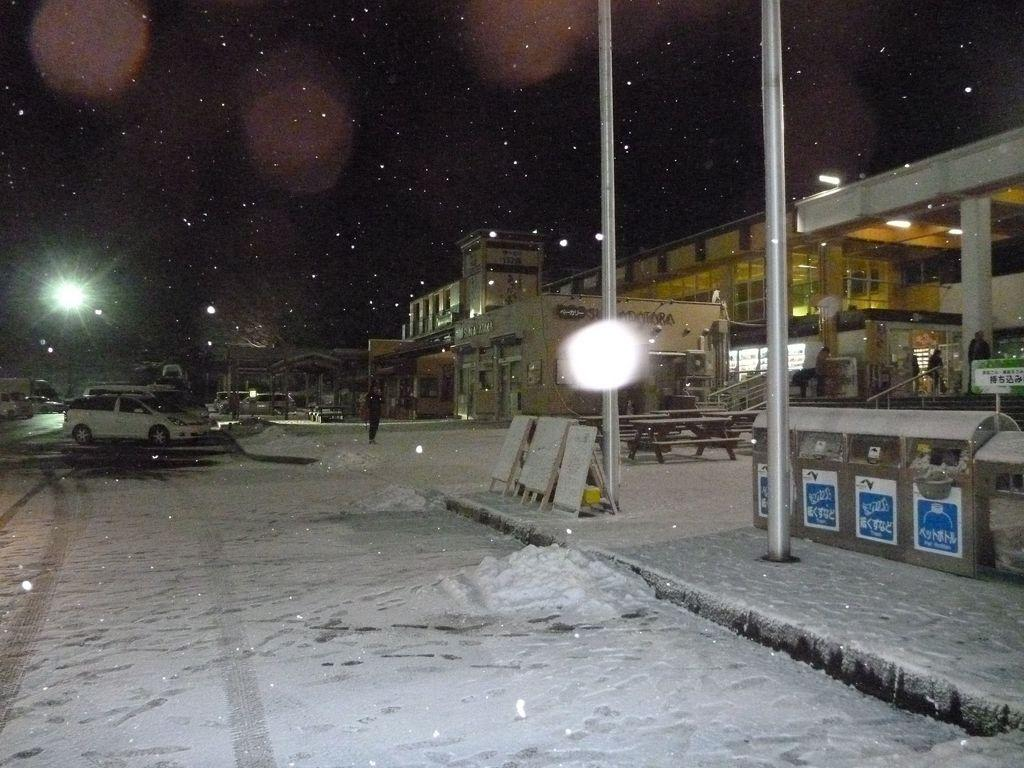What type of structures can be seen in the image? There are buildings in the image. What other objects can be seen in the image? There are poles, stairs, benches, boards, dustbins, vehicles, and lights visible in the image. Are there any people present in the image? Yes, there are people in the image. What is the weather like in the image? There is snow at the bottom of the image, indicating a cold or wintry weather condition. What is the average income of the insects in the image? There are no insects present in the image, so it is not possible to determine their average income. 